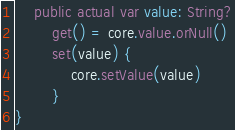Convert code to text. <code><loc_0><loc_0><loc_500><loc_500><_Kotlin_>    public actual var value: String?
        get() = core.value.orNull()
        set(value) {
            core.setValue(value)
        }
}
</code> 